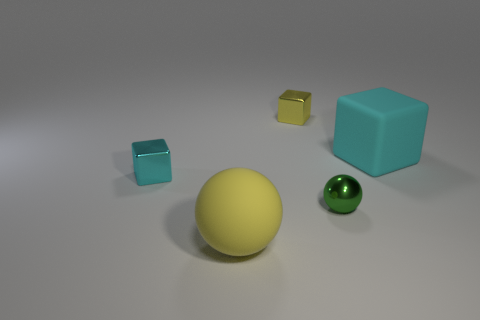There is a green metallic ball; is its size the same as the cyan block that is behind the cyan shiny cube?
Provide a succinct answer. No. The other shiny cube that is the same size as the cyan shiny cube is what color?
Your answer should be very brief. Yellow. The green sphere is what size?
Offer a very short reply. Small. Do the cyan block that is to the left of the big rubber sphere and the green thing have the same material?
Offer a terse response. Yes. Is the shape of the large yellow matte thing the same as the tiny yellow object?
Ensure brevity in your answer.  No. What is the shape of the big matte object that is on the right side of the tiny metal object on the right side of the tiny metallic cube that is behind the large cyan thing?
Provide a succinct answer. Cube. There is a large object to the right of the yellow metallic thing; is it the same shape as the rubber thing that is in front of the tiny green thing?
Your response must be concise. No. Are there any small yellow objects that have the same material as the green ball?
Your answer should be compact. Yes. What color is the matte thing that is behind the cyan thing that is to the left of the yellow block behind the tiny cyan object?
Keep it short and to the point. Cyan. Do the small cube that is left of the tiny yellow metal block and the yellow thing that is behind the tiny ball have the same material?
Ensure brevity in your answer.  Yes. 